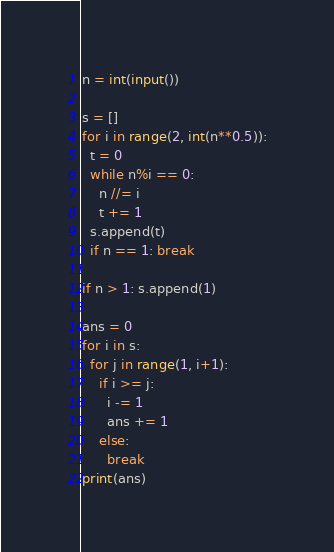<code> <loc_0><loc_0><loc_500><loc_500><_Python_>n = int(input())

s = []
for i in range(2, int(n**0.5)):
  t = 0
  while n%i == 0:
    n //= i
    t += 1
  s.append(t)
  if n == 1: break

if n > 1: s.append(1)
  
ans = 0
for i in s:
  for j in range(1, i+1):
    if i >= j:
      i -= 1
      ans += 1
    else:
      break
print(ans)</code> 